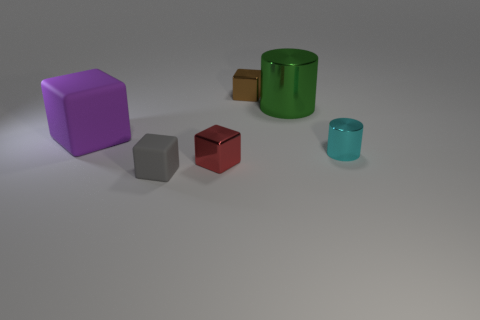Add 1 green objects. How many objects exist? 7 Subtract all cylinders. How many objects are left? 4 Add 5 shiny cylinders. How many shiny cylinders are left? 7 Add 1 matte objects. How many matte objects exist? 3 Subtract 0 cyan spheres. How many objects are left? 6 Subtract all small red metal blocks. Subtract all small shiny things. How many objects are left? 2 